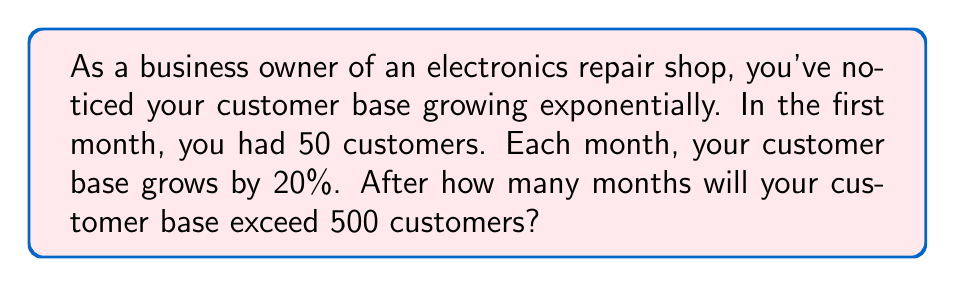Teach me how to tackle this problem. Let's approach this step-by-step:

1) We start with an initial customer base of 50 and a growth rate of 20% per month.

2) The exponential growth formula is:

   $$ A = P(1 + r)^t $$

   Where:
   $A$ = final amount
   $P$ = initial amount (50 in this case)
   $r$ = growth rate (0.20 or 20% in this case)
   $t$ = time (number of months, which is what we're solving for)

3) We want to find when $A$ exceeds 500. So we set up the inequality:

   $$ 500 < 50(1 + 0.20)^t $$

4) Simplify:

   $$ 500 < 50(1.20)^t $$

5) Divide both sides by 50:

   $$ 10 < (1.20)^t $$

6) Take the natural log of both sides:

   $$ \ln(10) < t \cdot \ln(1.20) $$

7) Divide both sides by $\ln(1.20)$:

   $$ \frac{\ln(10)}{\ln(1.20)} < t $$

8) Calculate:

   $$ 11.53 < t $$

9) Since $t$ represents months and must be a whole number, we round up to the next integer.
Answer: The customer base will exceed 500 after 12 months. 